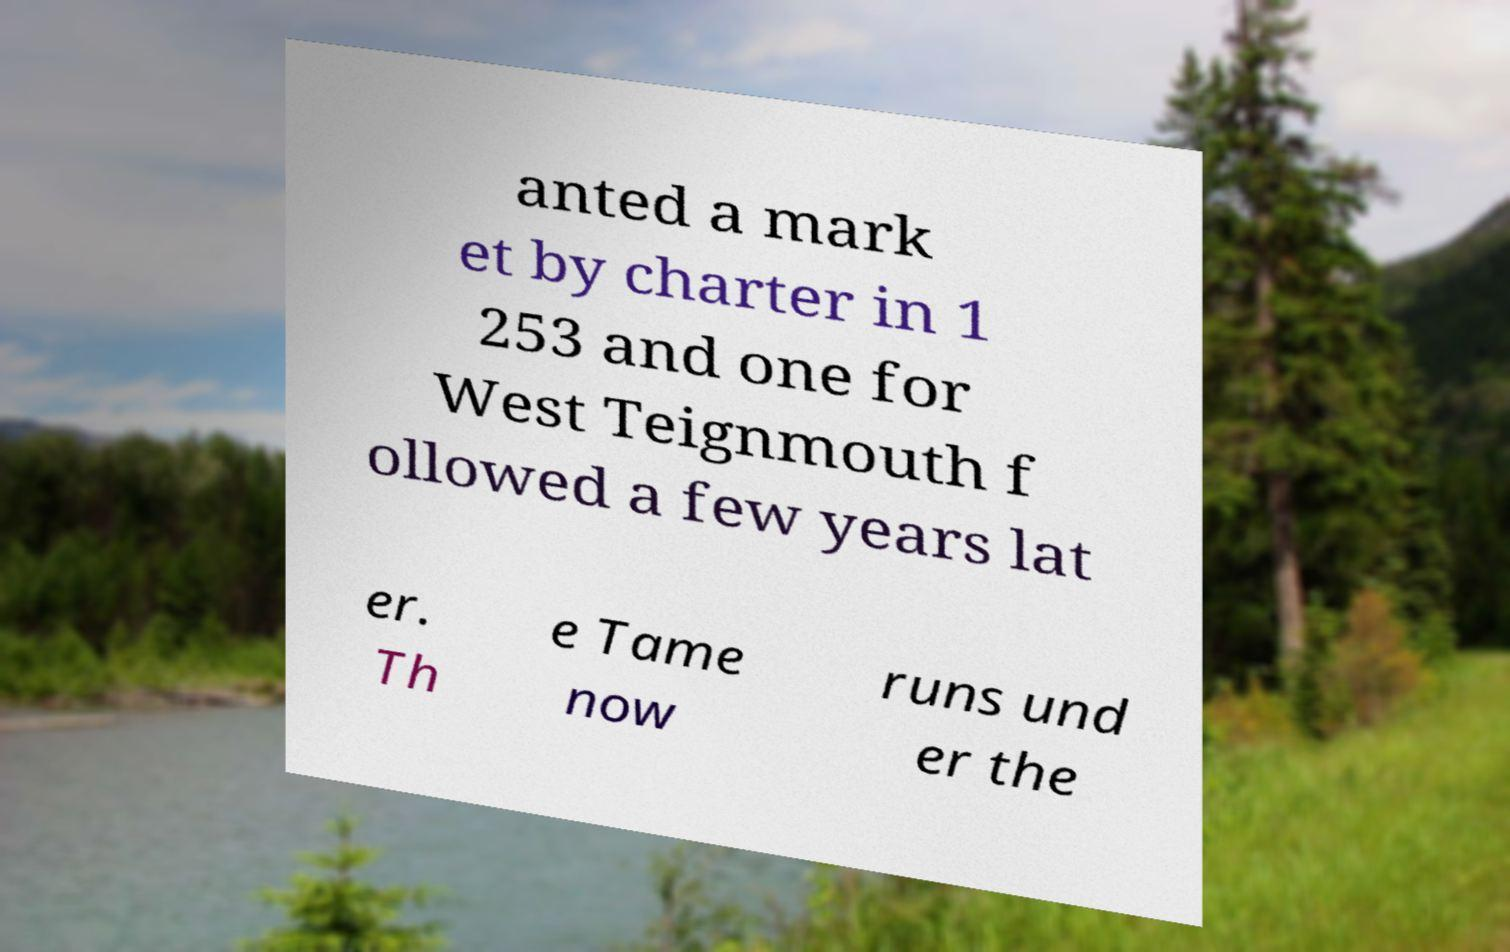Please read and relay the text visible in this image. What does it say? anted a mark et by charter in 1 253 and one for West Teignmouth f ollowed a few years lat er. Th e Tame now runs und er the 